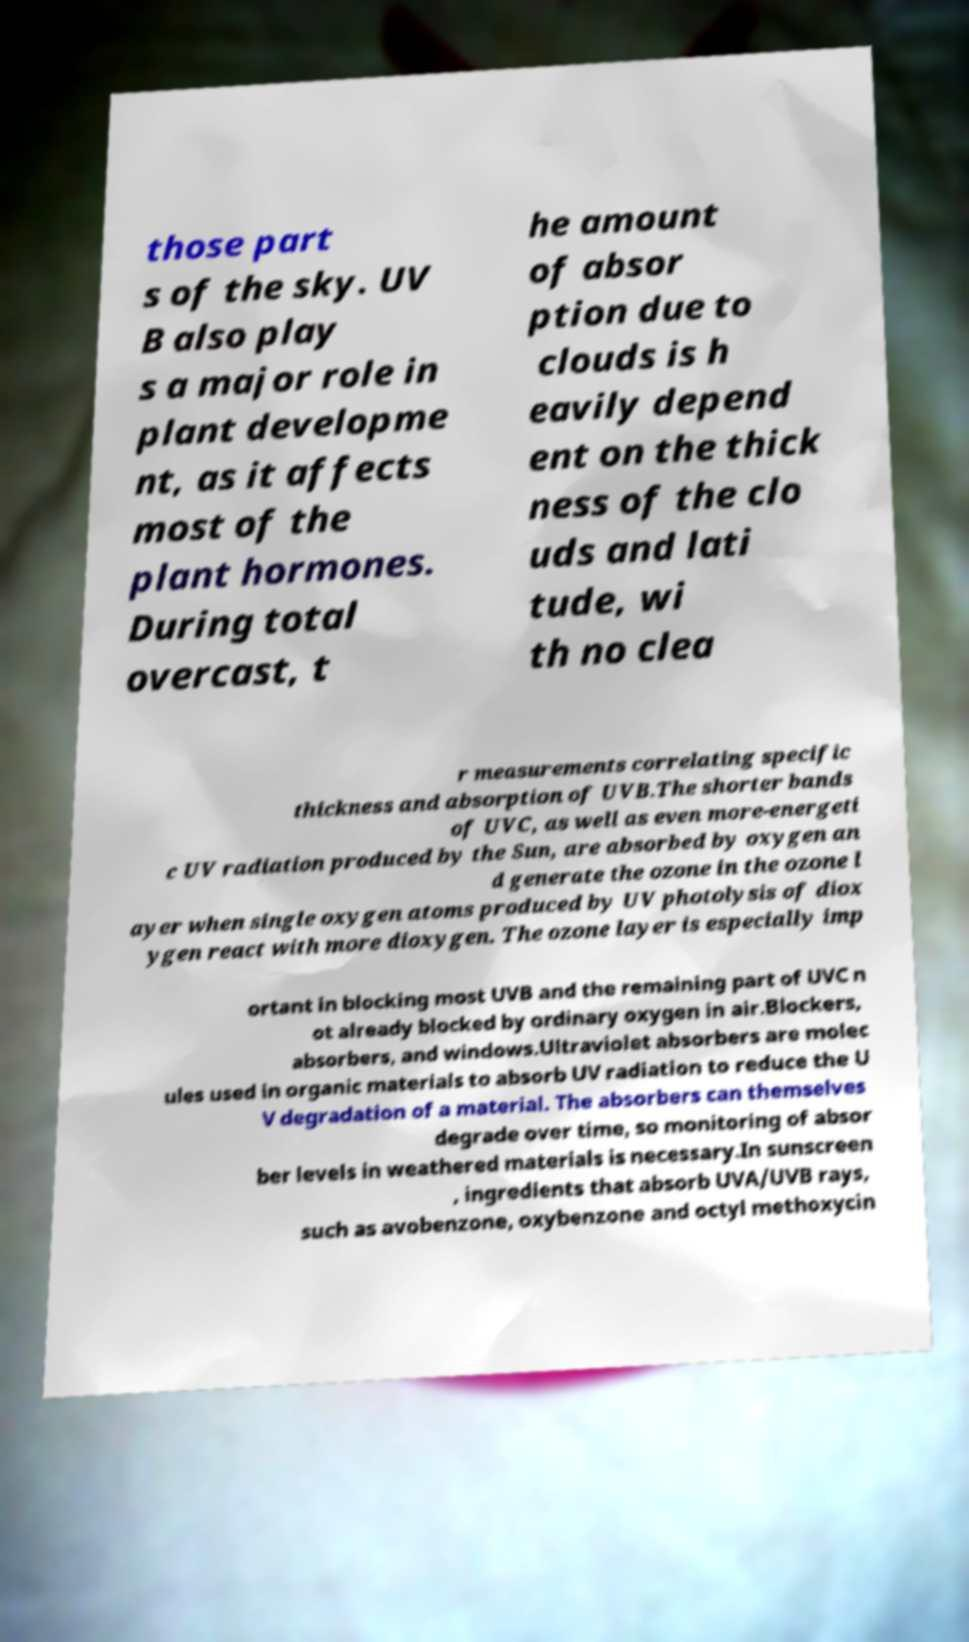I need the written content from this picture converted into text. Can you do that? those part s of the sky. UV B also play s a major role in plant developme nt, as it affects most of the plant hormones. During total overcast, t he amount of absor ption due to clouds is h eavily depend ent on the thick ness of the clo uds and lati tude, wi th no clea r measurements correlating specific thickness and absorption of UVB.The shorter bands of UVC, as well as even more-energeti c UV radiation produced by the Sun, are absorbed by oxygen an d generate the ozone in the ozone l ayer when single oxygen atoms produced by UV photolysis of diox ygen react with more dioxygen. The ozone layer is especially imp ortant in blocking most UVB and the remaining part of UVC n ot already blocked by ordinary oxygen in air.Blockers, absorbers, and windows.Ultraviolet absorbers are molec ules used in organic materials to absorb UV radiation to reduce the U V degradation of a material. The absorbers can themselves degrade over time, so monitoring of absor ber levels in weathered materials is necessary.In sunscreen , ingredients that absorb UVA/UVB rays, such as avobenzone, oxybenzone and octyl methoxycin 